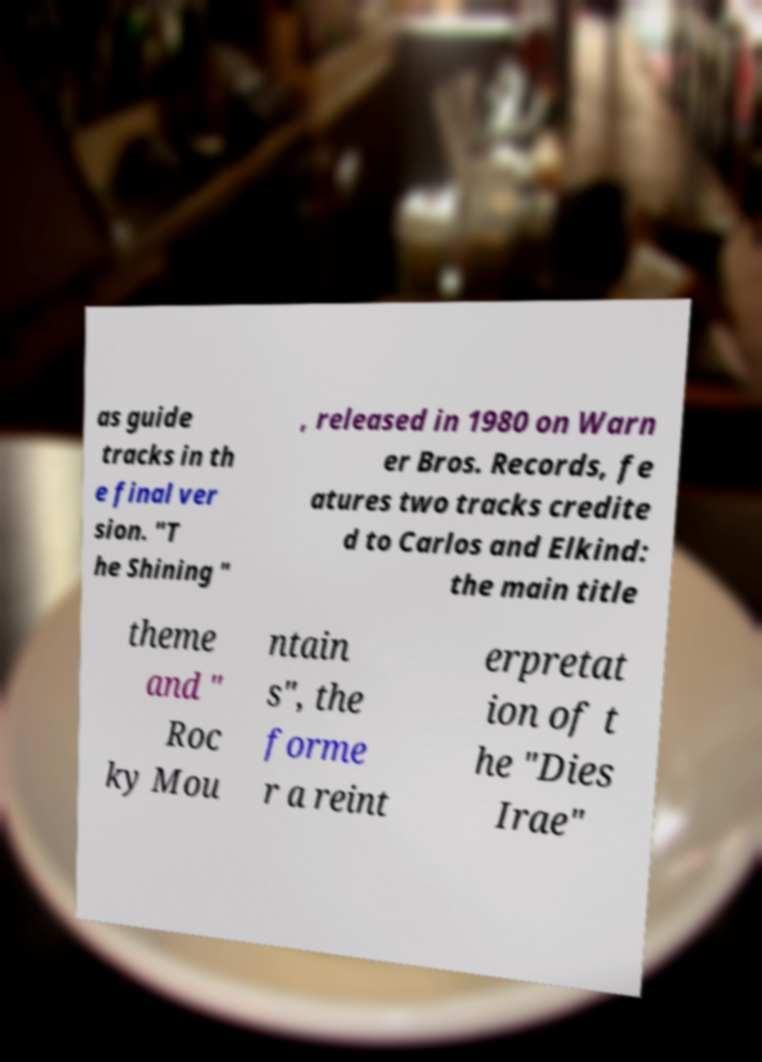Please identify and transcribe the text found in this image. as guide tracks in th e final ver sion. "T he Shining " , released in 1980 on Warn er Bros. Records, fe atures two tracks credite d to Carlos and Elkind: the main title theme and " Roc ky Mou ntain s", the forme r a reint erpretat ion of t he "Dies Irae" 